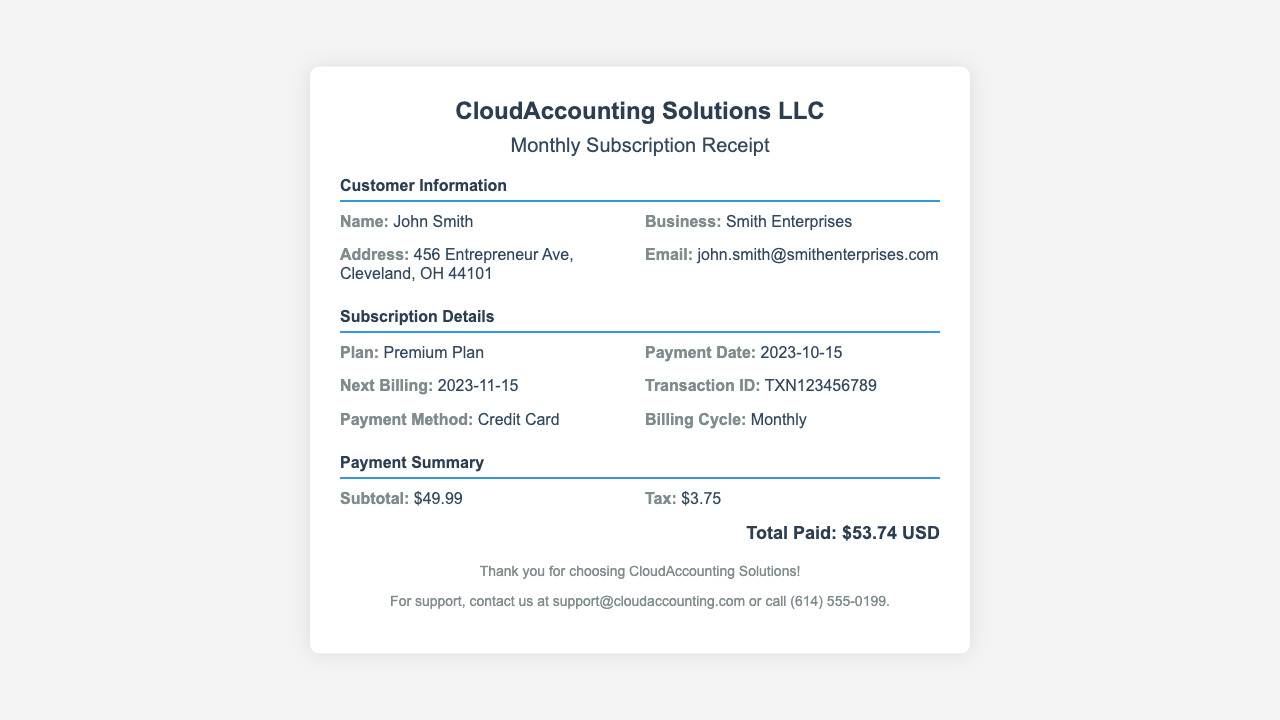What is the plan chosen? The document specifies the subscription plan that has been selected, which is listed in the "Subscription Details" section.
Answer: Premium Plan What is the payment date? The payment date is provided in the "Subscription Details" section, indicating when the payment was made.
Answer: 2023-10-15 What is the transaction ID? The transaction ID is detailed in the "Subscription Details" section as a unique identifier for this transaction.
Answer: TXN123456789 What is the subtotal amount? The subtotal amount is listed in the "Payment Summary" section, showing the cost before tax.
Answer: $49.99 What is the total paid? The "Payment Summary" section provides the final amount that was paid including tax, which is the total of the transaction.
Answer: $53.74 USD When is the next billing date? This information can be found in the "Subscription Details" section and indicates when the next payment will be due.
Answer: 2023-11-15 What is the payment method used? The payment method is mentioned in the "Subscription Details" section, specifying how the payment was processed.
Answer: Credit Card How much tax was charged? The amount of tax charged is detailed in the "Payment Summary" section, showing the additional cost due to taxation.
Answer: $3.75 What is the address associated with the customer? The address of the customer is provided in the "Customer Information" section, indicating where they are located.
Answer: 456 Entrepreneur Ave, Cleveland, OH 44101 What company issued this receipt? The company name is listed prominently at the top of the receipt, indicating the service provider of the subscription.
Answer: CloudAccounting Solutions LLC 